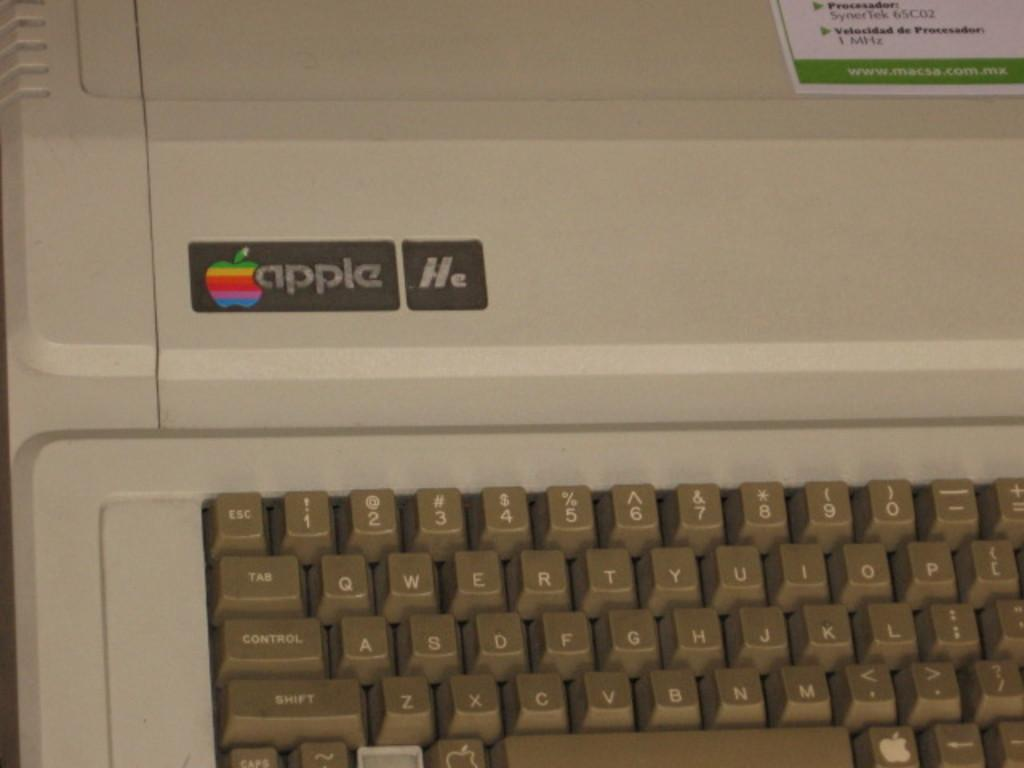<image>
Summarize the visual content of the image. an old fashioned keyboard with an apple logo and the word apple 